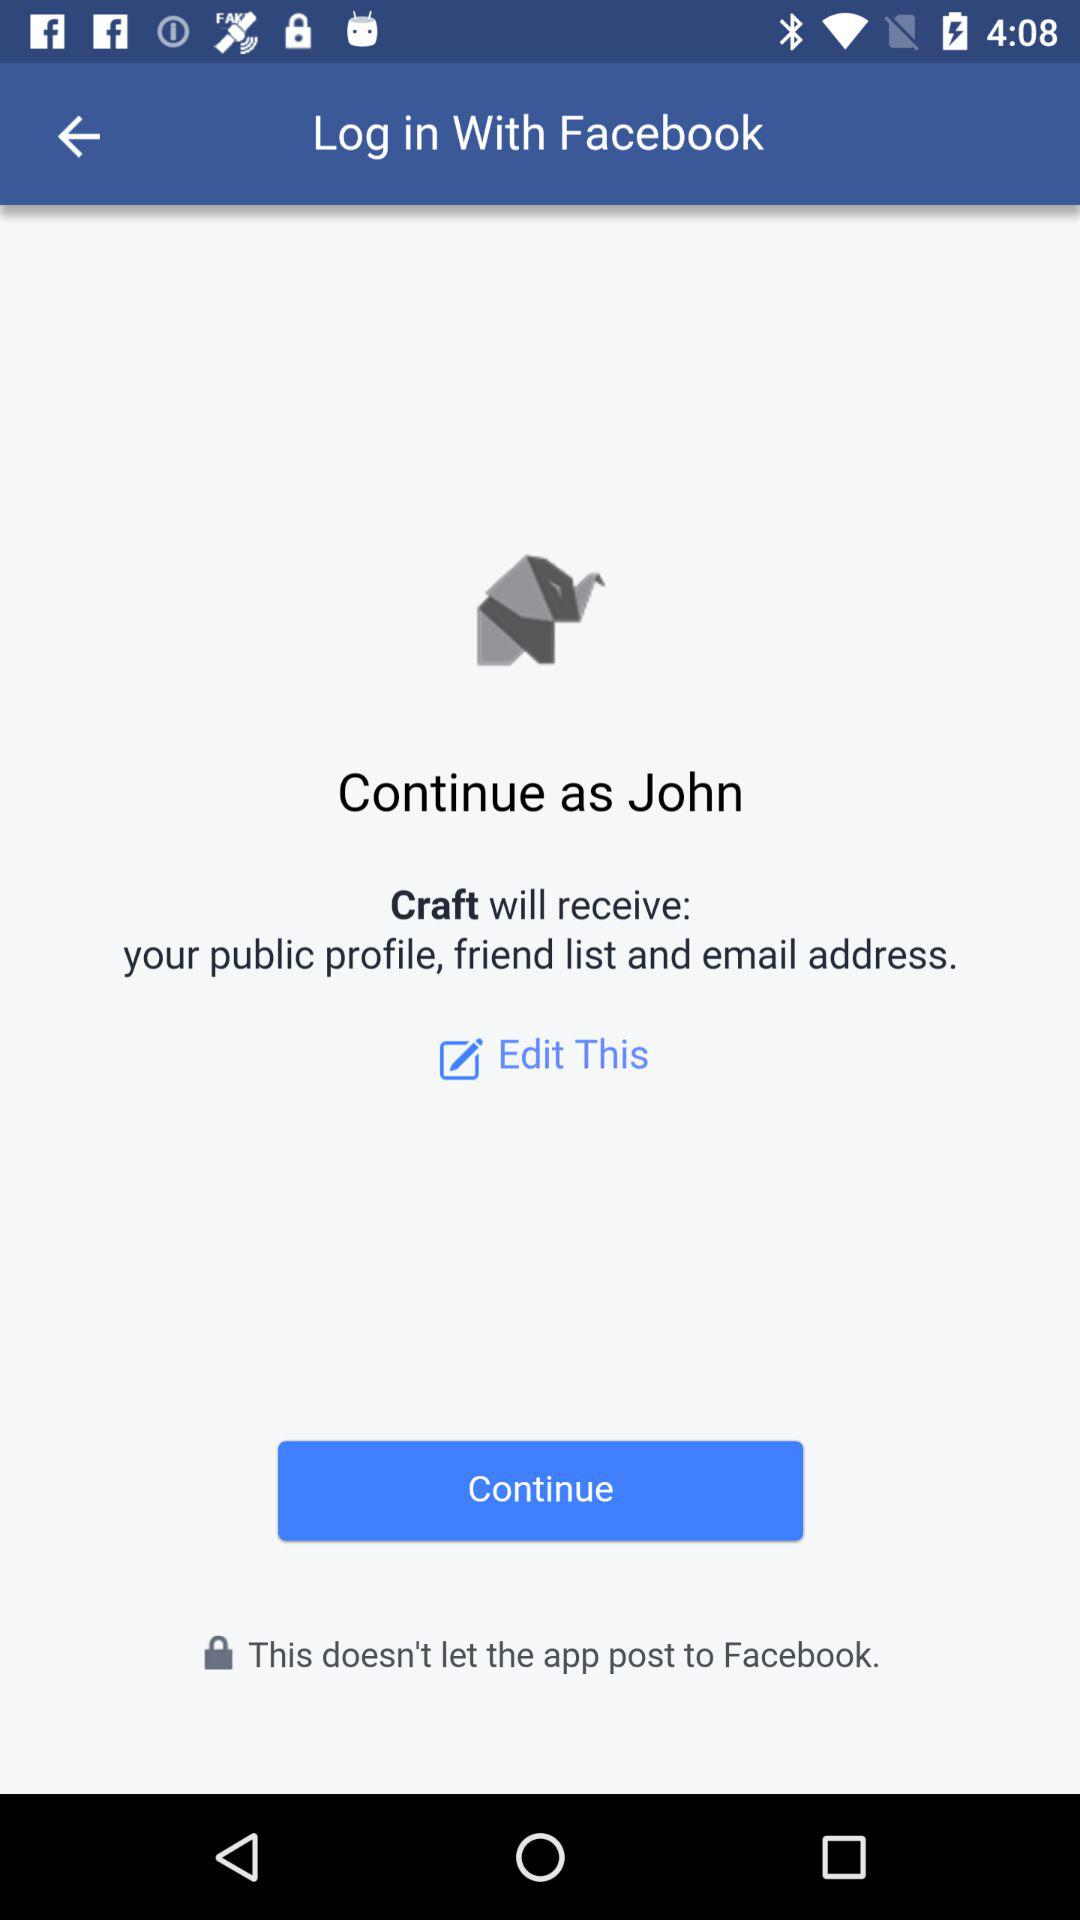What is the name of the user? The name of the user is John. 